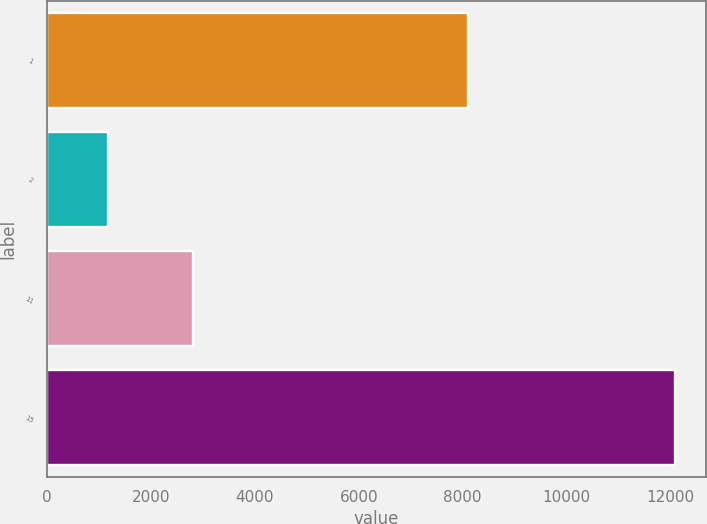Convert chart to OTSL. <chart><loc_0><loc_0><loc_500><loc_500><bar_chart><fcel>1<fcel>2<fcel>11<fcel>15<nl><fcel>8098<fcel>1169<fcel>2813<fcel>12085<nl></chart> 